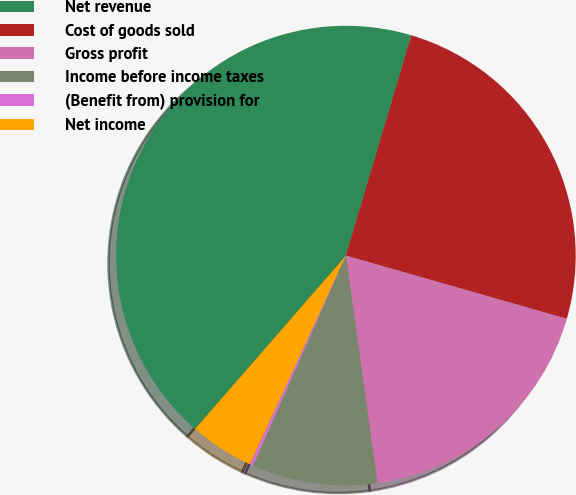<chart> <loc_0><loc_0><loc_500><loc_500><pie_chart><fcel>Net revenue<fcel>Cost of goods sold<fcel>Gross profit<fcel>Income before income taxes<fcel>(Benefit from) provision for<fcel>Net income<nl><fcel>43.2%<fcel>24.83%<fcel>18.37%<fcel>8.83%<fcel>0.23%<fcel>4.53%<nl></chart> 